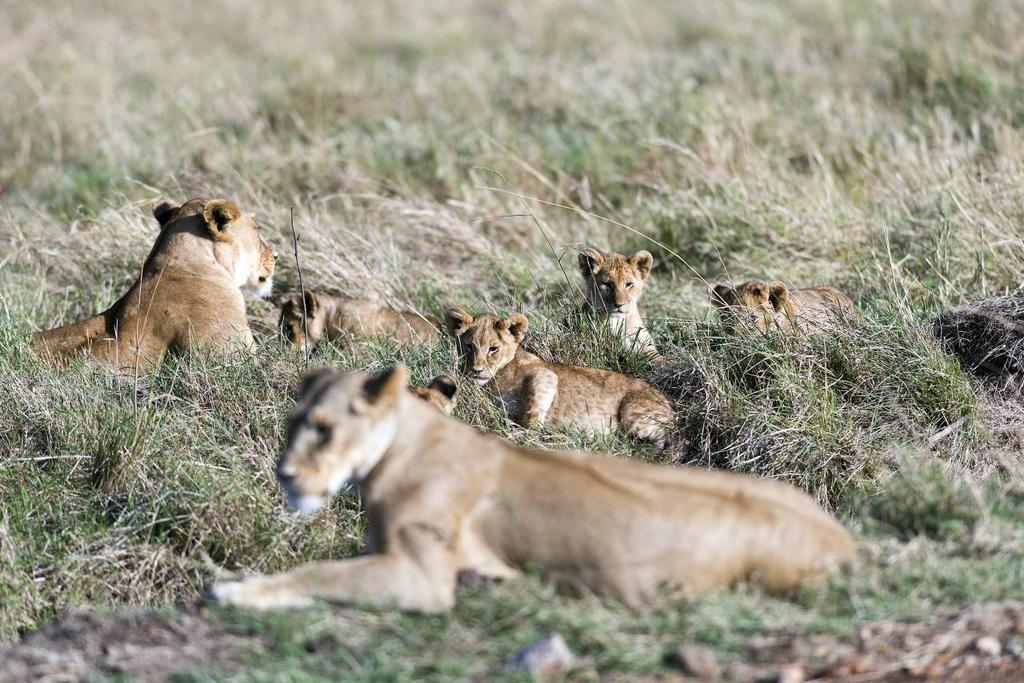What is the setting of the image? The image is an outside view. What can be seen at the bottom of the image? There is a rock at the bottom of the image. What type of vegetation is present on the ground? There is grass on the ground. What animals are visible in the image? There are lions laying on the ground in the middle of the image. What is the fastest route to downtown from the location in the image? The image does not provide information about the location or the fastest route to downtown. 